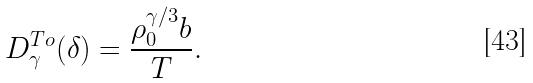<formula> <loc_0><loc_0><loc_500><loc_500>D _ { \gamma } ^ { T o } ( \delta ) = \frac { \rho _ { 0 } ^ { \gamma / 3 } b } T .</formula> 